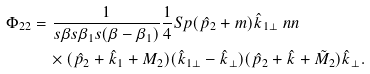Convert formula to latex. <formula><loc_0><loc_0><loc_500><loc_500>\Phi _ { 2 2 } & = \frac { 1 } { s \beta s \beta _ { 1 } s ( \beta - \beta _ { 1 } ) } \frac { 1 } { 4 } S p ( \hat { p } _ { 2 } + m ) \hat { k } _ { 1 \bot } \ n n \\ & \quad \times ( \hat { p } _ { 2 } + \hat { k } _ { 1 } + M _ { 2 } ) ( \hat { k } _ { 1 \bot } - \hat { k } _ { \bot } ) ( \hat { p } _ { 2 } + \hat { k } + \tilde { M } _ { 2 } ) \hat { k } _ { \bot } .</formula> 